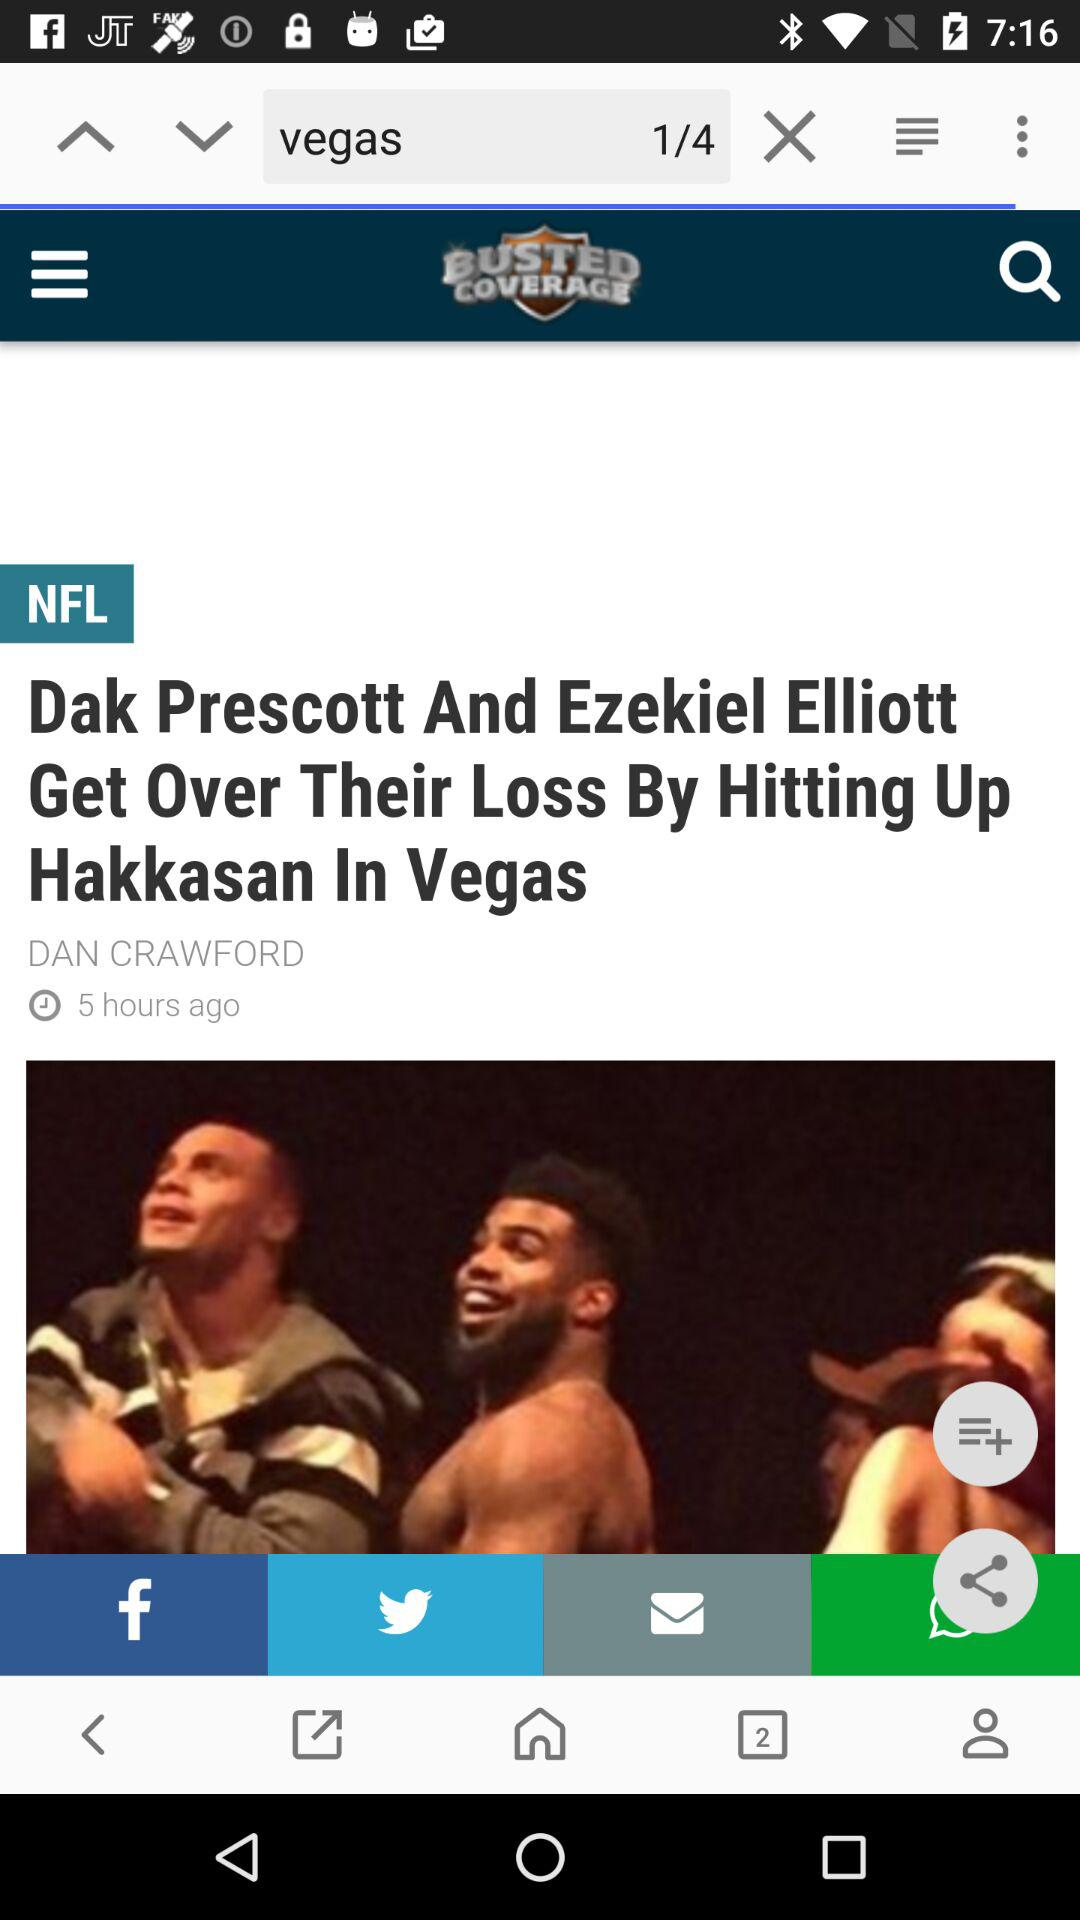Who is the author of the article? The author of the article is Dan Crawford. 